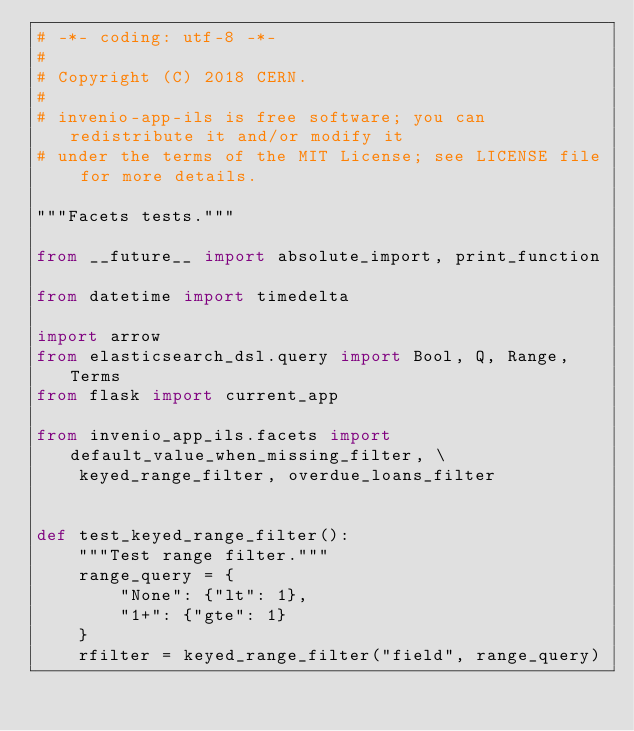<code> <loc_0><loc_0><loc_500><loc_500><_Python_># -*- coding: utf-8 -*-
#
# Copyright (C) 2018 CERN.
#
# invenio-app-ils is free software; you can redistribute it and/or modify it
# under the terms of the MIT License; see LICENSE file for more details.

"""Facets tests."""

from __future__ import absolute_import, print_function

from datetime import timedelta

import arrow
from elasticsearch_dsl.query import Bool, Q, Range, Terms
from flask import current_app

from invenio_app_ils.facets import default_value_when_missing_filter, \
    keyed_range_filter, overdue_loans_filter


def test_keyed_range_filter():
    """Test range filter."""
    range_query = {
        "None": {"lt": 1},
        "1+": {"gte": 1}
    }
    rfilter = keyed_range_filter("field", range_query)
</code> 